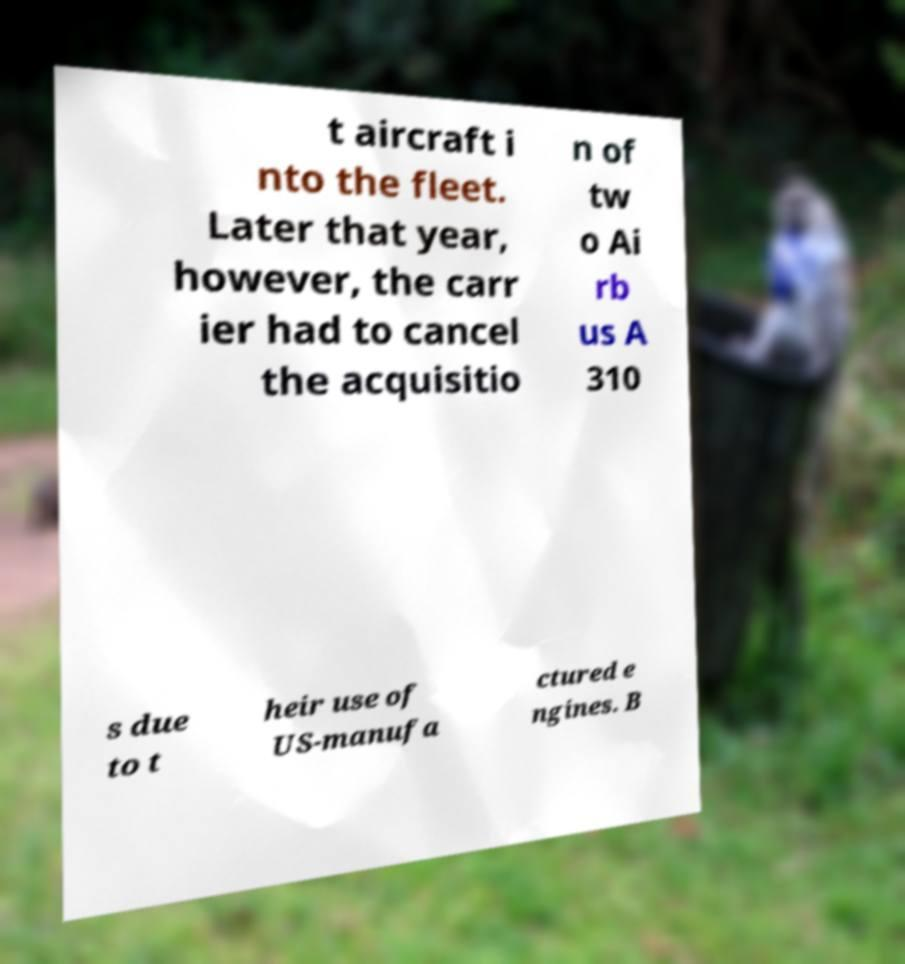What messages or text are displayed in this image? I need them in a readable, typed format. t aircraft i nto the fleet. Later that year, however, the carr ier had to cancel the acquisitio n of tw o Ai rb us A 310 s due to t heir use of US-manufa ctured e ngines. B 